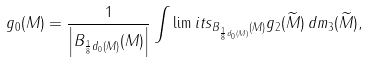Convert formula to latex. <formula><loc_0><loc_0><loc_500><loc_500>g _ { 0 } ( M ) = \frac { 1 } { \left | B _ { \frac { 1 } { 8 } d _ { 0 } ( M ) } ( M ) \right | } \int \lim i t s _ { B _ { \frac { 1 } { 8 } d _ { 0 } ( M ) } ( M ) } g _ { 2 } ( \widetilde { M } ) \, d m _ { 3 } ( \widetilde { M } ) ,</formula> 